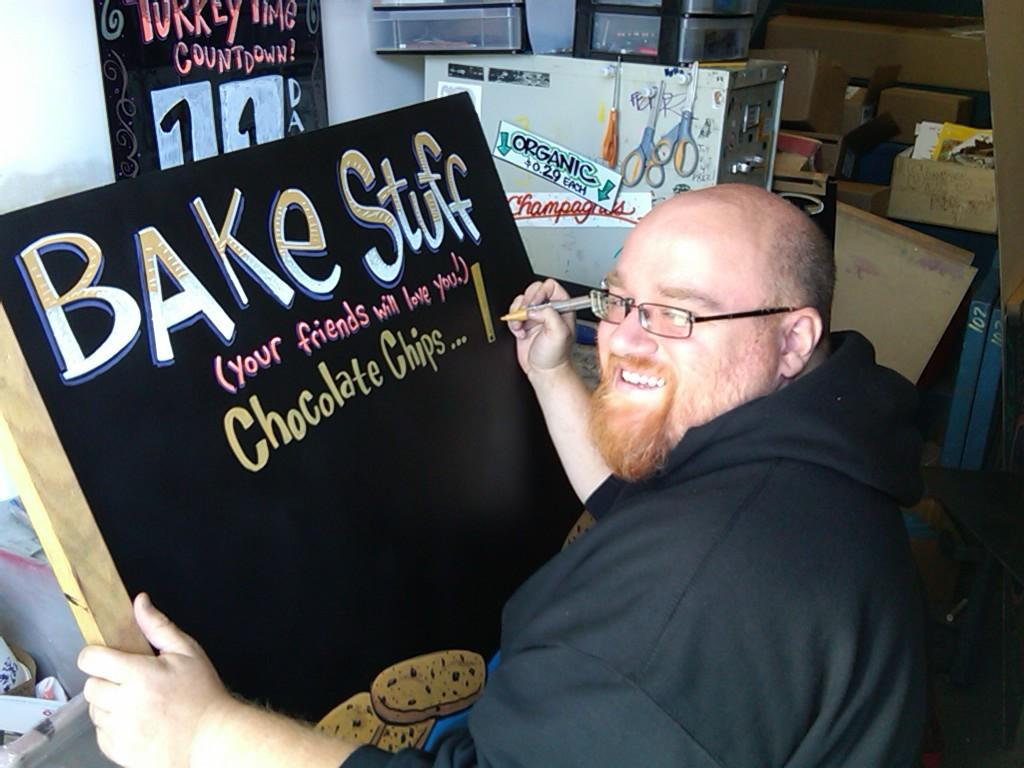<image>
Render a clear and concise summary of the photo. A man writing on a sign called Bake Stuff and Chocolate Chips. 